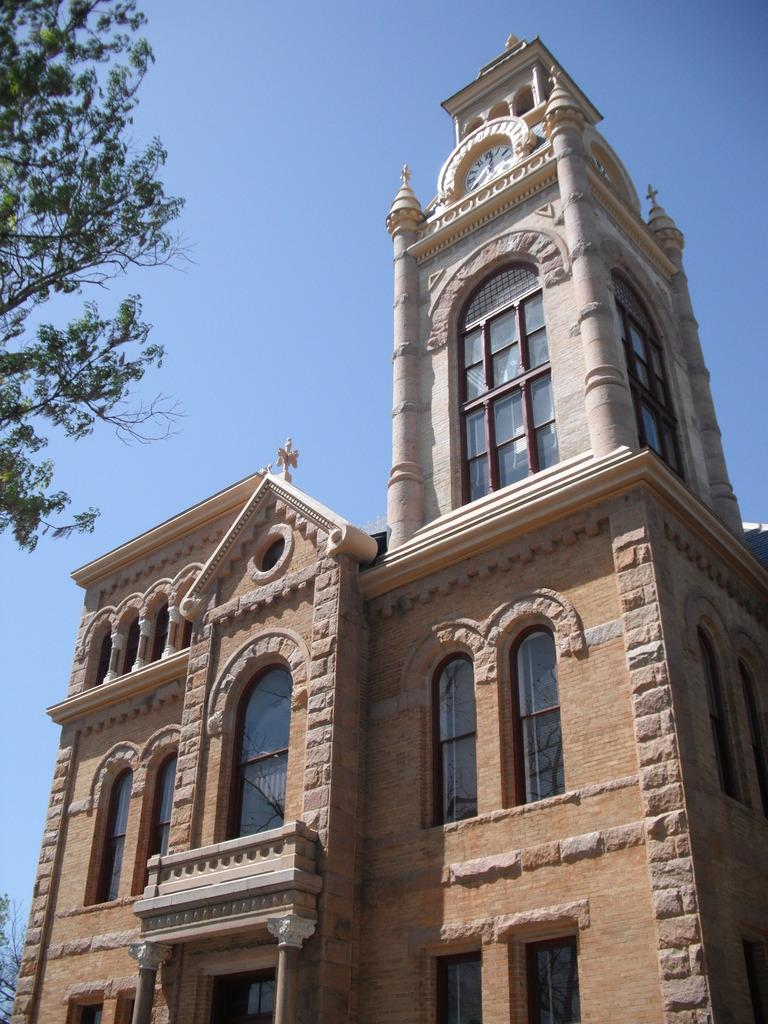What type of structure is present in the image? There is a building in the image. What feature is present on the building? The building has a clock. What other details can be observed about the building? The building has windows. What can be seen in the background of the image? There are trees and the sky visible in the image. How would you describe the sky in the image? The sky appears cloudy in the image. What type of error can be seen in the image? There is no error present in the image; it is a clear depiction of a building with a clock, windows, trees, and a cloudy sky. What is the stomach doing in the image? There is no stomach present in the image; it is a picture of a building and its surroundings. 